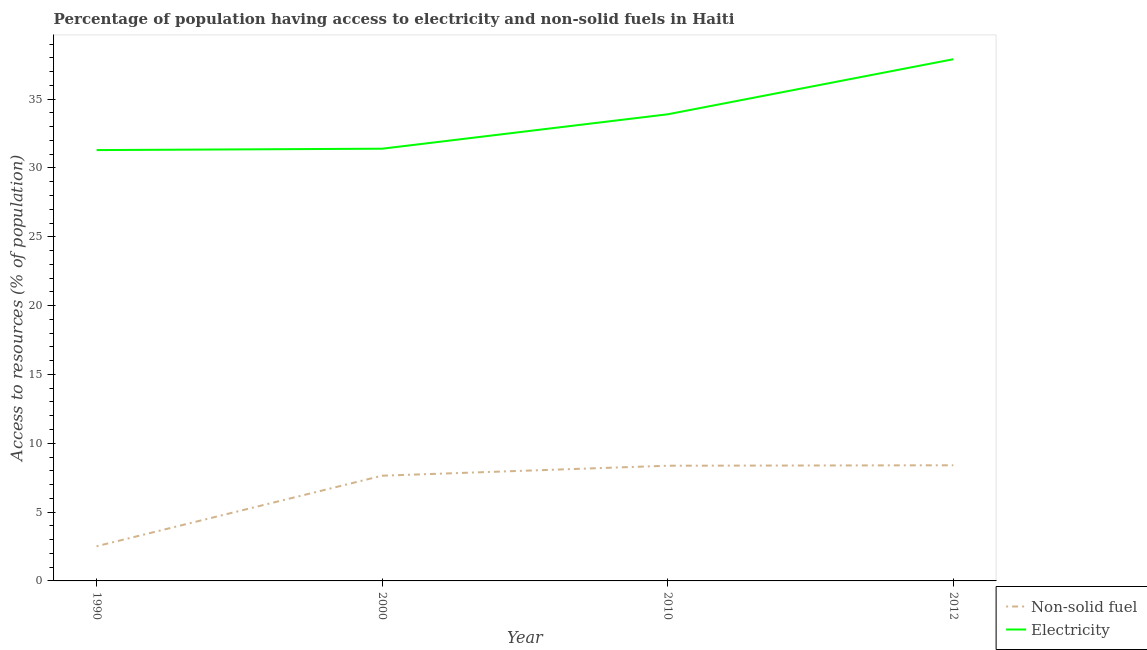Is the number of lines equal to the number of legend labels?
Offer a very short reply. Yes. What is the percentage of population having access to electricity in 1990?
Offer a very short reply. 31.3. Across all years, what is the maximum percentage of population having access to non-solid fuel?
Offer a terse response. 8.4. Across all years, what is the minimum percentage of population having access to electricity?
Your answer should be very brief. 31.3. In which year was the percentage of population having access to non-solid fuel maximum?
Offer a terse response. 2012. What is the total percentage of population having access to electricity in the graph?
Make the answer very short. 134.5. What is the difference between the percentage of population having access to non-solid fuel in 1990 and the percentage of population having access to electricity in 2000?
Offer a terse response. -28.88. What is the average percentage of population having access to electricity per year?
Your response must be concise. 33.62. In the year 2010, what is the difference between the percentage of population having access to electricity and percentage of population having access to non-solid fuel?
Provide a succinct answer. 25.53. In how many years, is the percentage of population having access to electricity greater than 29 %?
Offer a very short reply. 4. What is the ratio of the percentage of population having access to electricity in 1990 to that in 2012?
Provide a short and direct response. 0.83. Is the percentage of population having access to electricity in 2010 less than that in 2012?
Provide a succinct answer. Yes. What is the difference between the highest and the second highest percentage of population having access to non-solid fuel?
Provide a short and direct response. 0.03. What is the difference between the highest and the lowest percentage of population having access to electricity?
Give a very brief answer. 6.6. In how many years, is the percentage of population having access to electricity greater than the average percentage of population having access to electricity taken over all years?
Your answer should be very brief. 2. Is the sum of the percentage of population having access to electricity in 2010 and 2012 greater than the maximum percentage of population having access to non-solid fuel across all years?
Your response must be concise. Yes. Does the percentage of population having access to electricity monotonically increase over the years?
Ensure brevity in your answer.  Yes. Is the percentage of population having access to electricity strictly greater than the percentage of population having access to non-solid fuel over the years?
Make the answer very short. Yes. How many lines are there?
Your answer should be very brief. 2. How many years are there in the graph?
Ensure brevity in your answer.  4. What is the difference between two consecutive major ticks on the Y-axis?
Make the answer very short. 5. Are the values on the major ticks of Y-axis written in scientific E-notation?
Ensure brevity in your answer.  No. Does the graph contain any zero values?
Your response must be concise. No. Does the graph contain grids?
Give a very brief answer. No. What is the title of the graph?
Your answer should be very brief. Percentage of population having access to electricity and non-solid fuels in Haiti. What is the label or title of the X-axis?
Your response must be concise. Year. What is the label or title of the Y-axis?
Ensure brevity in your answer.  Access to resources (% of population). What is the Access to resources (% of population) of Non-solid fuel in 1990?
Your answer should be very brief. 2.52. What is the Access to resources (% of population) of Electricity in 1990?
Your response must be concise. 31.3. What is the Access to resources (% of population) of Non-solid fuel in 2000?
Keep it short and to the point. 7.64. What is the Access to resources (% of population) of Electricity in 2000?
Your response must be concise. 31.4. What is the Access to resources (% of population) in Non-solid fuel in 2010?
Make the answer very short. 8.37. What is the Access to resources (% of population) in Electricity in 2010?
Ensure brevity in your answer.  33.9. What is the Access to resources (% of population) of Non-solid fuel in 2012?
Your response must be concise. 8.4. What is the Access to resources (% of population) of Electricity in 2012?
Your response must be concise. 37.9. Across all years, what is the maximum Access to resources (% of population) of Non-solid fuel?
Give a very brief answer. 8.4. Across all years, what is the maximum Access to resources (% of population) in Electricity?
Offer a very short reply. 37.9. Across all years, what is the minimum Access to resources (% of population) of Non-solid fuel?
Your answer should be compact. 2.52. Across all years, what is the minimum Access to resources (% of population) in Electricity?
Offer a terse response. 31.3. What is the total Access to resources (% of population) in Non-solid fuel in the graph?
Offer a very short reply. 26.93. What is the total Access to resources (% of population) in Electricity in the graph?
Provide a short and direct response. 134.5. What is the difference between the Access to resources (% of population) in Non-solid fuel in 1990 and that in 2000?
Offer a terse response. -5.13. What is the difference between the Access to resources (% of population) in Electricity in 1990 and that in 2000?
Give a very brief answer. -0.1. What is the difference between the Access to resources (% of population) in Non-solid fuel in 1990 and that in 2010?
Your answer should be compact. -5.85. What is the difference between the Access to resources (% of population) in Electricity in 1990 and that in 2010?
Provide a succinct answer. -2.6. What is the difference between the Access to resources (% of population) of Non-solid fuel in 1990 and that in 2012?
Keep it short and to the point. -5.88. What is the difference between the Access to resources (% of population) of Electricity in 1990 and that in 2012?
Your answer should be very brief. -6.6. What is the difference between the Access to resources (% of population) in Non-solid fuel in 2000 and that in 2010?
Provide a short and direct response. -0.72. What is the difference between the Access to resources (% of population) in Non-solid fuel in 2000 and that in 2012?
Provide a short and direct response. -0.76. What is the difference between the Access to resources (% of population) of Non-solid fuel in 2010 and that in 2012?
Give a very brief answer. -0.03. What is the difference between the Access to resources (% of population) in Electricity in 2010 and that in 2012?
Give a very brief answer. -4. What is the difference between the Access to resources (% of population) in Non-solid fuel in 1990 and the Access to resources (% of population) in Electricity in 2000?
Provide a short and direct response. -28.88. What is the difference between the Access to resources (% of population) in Non-solid fuel in 1990 and the Access to resources (% of population) in Electricity in 2010?
Provide a short and direct response. -31.38. What is the difference between the Access to resources (% of population) of Non-solid fuel in 1990 and the Access to resources (% of population) of Electricity in 2012?
Offer a terse response. -35.38. What is the difference between the Access to resources (% of population) in Non-solid fuel in 2000 and the Access to resources (% of population) in Electricity in 2010?
Give a very brief answer. -26.26. What is the difference between the Access to resources (% of population) of Non-solid fuel in 2000 and the Access to resources (% of population) of Electricity in 2012?
Ensure brevity in your answer.  -30.26. What is the difference between the Access to resources (% of population) of Non-solid fuel in 2010 and the Access to resources (% of population) of Electricity in 2012?
Your answer should be compact. -29.53. What is the average Access to resources (% of population) in Non-solid fuel per year?
Provide a short and direct response. 6.73. What is the average Access to resources (% of population) of Electricity per year?
Give a very brief answer. 33.62. In the year 1990, what is the difference between the Access to resources (% of population) in Non-solid fuel and Access to resources (% of population) in Electricity?
Provide a short and direct response. -28.78. In the year 2000, what is the difference between the Access to resources (% of population) of Non-solid fuel and Access to resources (% of population) of Electricity?
Give a very brief answer. -23.76. In the year 2010, what is the difference between the Access to resources (% of population) of Non-solid fuel and Access to resources (% of population) of Electricity?
Ensure brevity in your answer.  -25.53. In the year 2012, what is the difference between the Access to resources (% of population) of Non-solid fuel and Access to resources (% of population) of Electricity?
Offer a terse response. -29.5. What is the ratio of the Access to resources (% of population) of Non-solid fuel in 1990 to that in 2000?
Your answer should be very brief. 0.33. What is the ratio of the Access to resources (% of population) of Non-solid fuel in 1990 to that in 2010?
Provide a short and direct response. 0.3. What is the ratio of the Access to resources (% of population) in Electricity in 1990 to that in 2010?
Keep it short and to the point. 0.92. What is the ratio of the Access to resources (% of population) in Non-solid fuel in 1990 to that in 2012?
Provide a succinct answer. 0.3. What is the ratio of the Access to resources (% of population) in Electricity in 1990 to that in 2012?
Make the answer very short. 0.83. What is the ratio of the Access to resources (% of population) in Non-solid fuel in 2000 to that in 2010?
Keep it short and to the point. 0.91. What is the ratio of the Access to resources (% of population) in Electricity in 2000 to that in 2010?
Make the answer very short. 0.93. What is the ratio of the Access to resources (% of population) of Non-solid fuel in 2000 to that in 2012?
Keep it short and to the point. 0.91. What is the ratio of the Access to resources (% of population) in Electricity in 2000 to that in 2012?
Keep it short and to the point. 0.83. What is the ratio of the Access to resources (% of population) of Electricity in 2010 to that in 2012?
Offer a very short reply. 0.89. What is the difference between the highest and the second highest Access to resources (% of population) in Non-solid fuel?
Offer a terse response. 0.03. What is the difference between the highest and the lowest Access to resources (% of population) in Non-solid fuel?
Offer a very short reply. 5.88. What is the difference between the highest and the lowest Access to resources (% of population) in Electricity?
Provide a short and direct response. 6.6. 